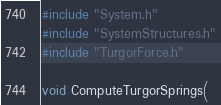<code> <loc_0><loc_0><loc_500><loc_500><_Cuda_>#include "System.h"
#include "SystemStructures.h"
#include "TurgorForce.h"

void ComputeTurgorSprings(</code> 